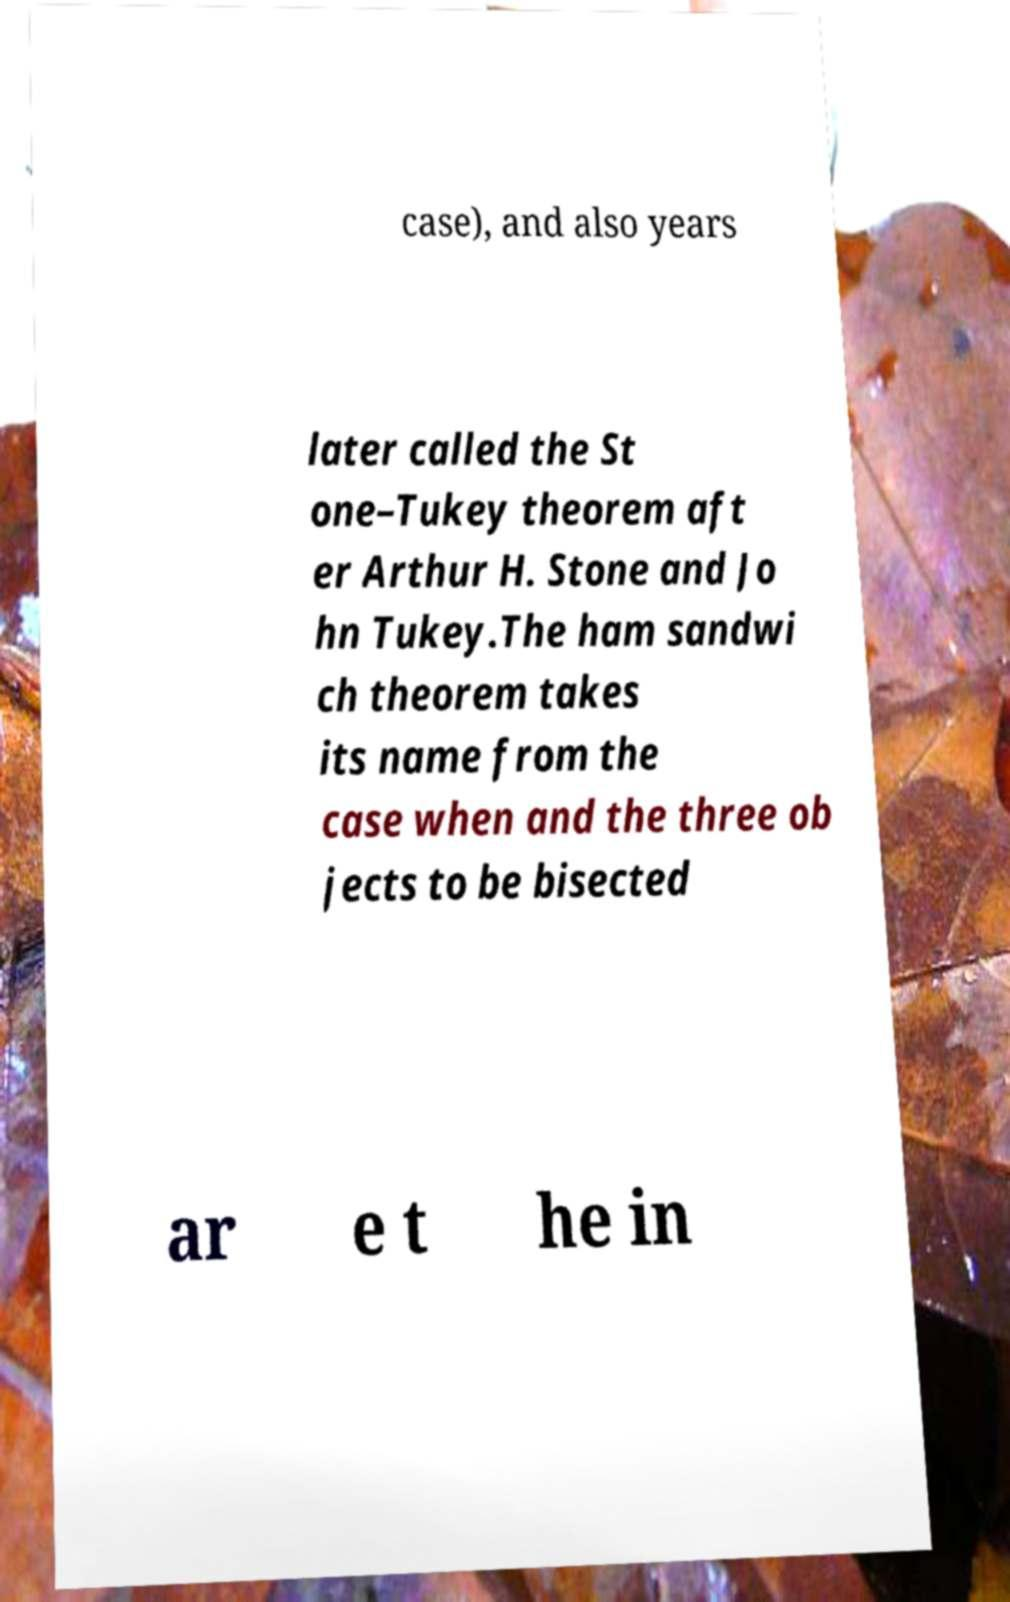What messages or text are displayed in this image? I need them in a readable, typed format. case), and also years later called the St one–Tukey theorem aft er Arthur H. Stone and Jo hn Tukey.The ham sandwi ch theorem takes its name from the case when and the three ob jects to be bisected ar e t he in 